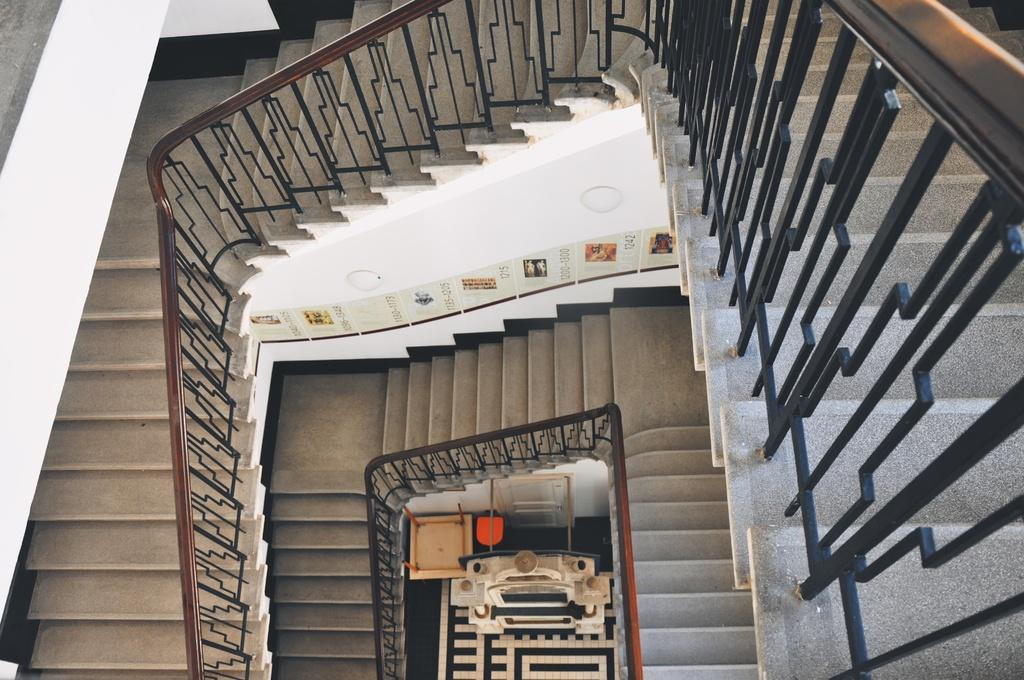What type of location is shown in the image? The image is an inside view of a room. What architectural feature can be seen in the background of the image? There are stairs visible in the background of the image. What type of furniture is present at the bottom of the image? There are tables present at the bottom of the image. What type of soup is being served on the tables in the image? There is no soup present in the image; only tables are visible. What game is being played on the stairs in the image? There is no game being played on the stairs in the image; only the stairs themselves are visible. 